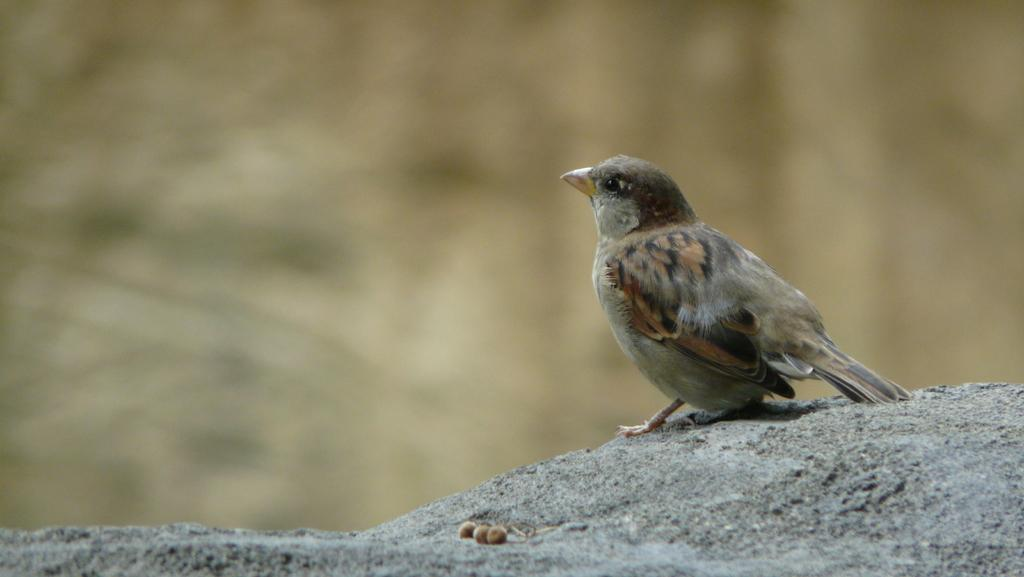What type of animal can be seen in the picture? There is a bird in the picture. Where is the bird located in the image? The bird is standing on a stone. What else can be seen in the picture besides the bird? There are seeds visible in the picture. What type of root can be seen growing near the bird in the picture? There is no root visible in the picture; it only features a bird standing on a stone and seeds. 